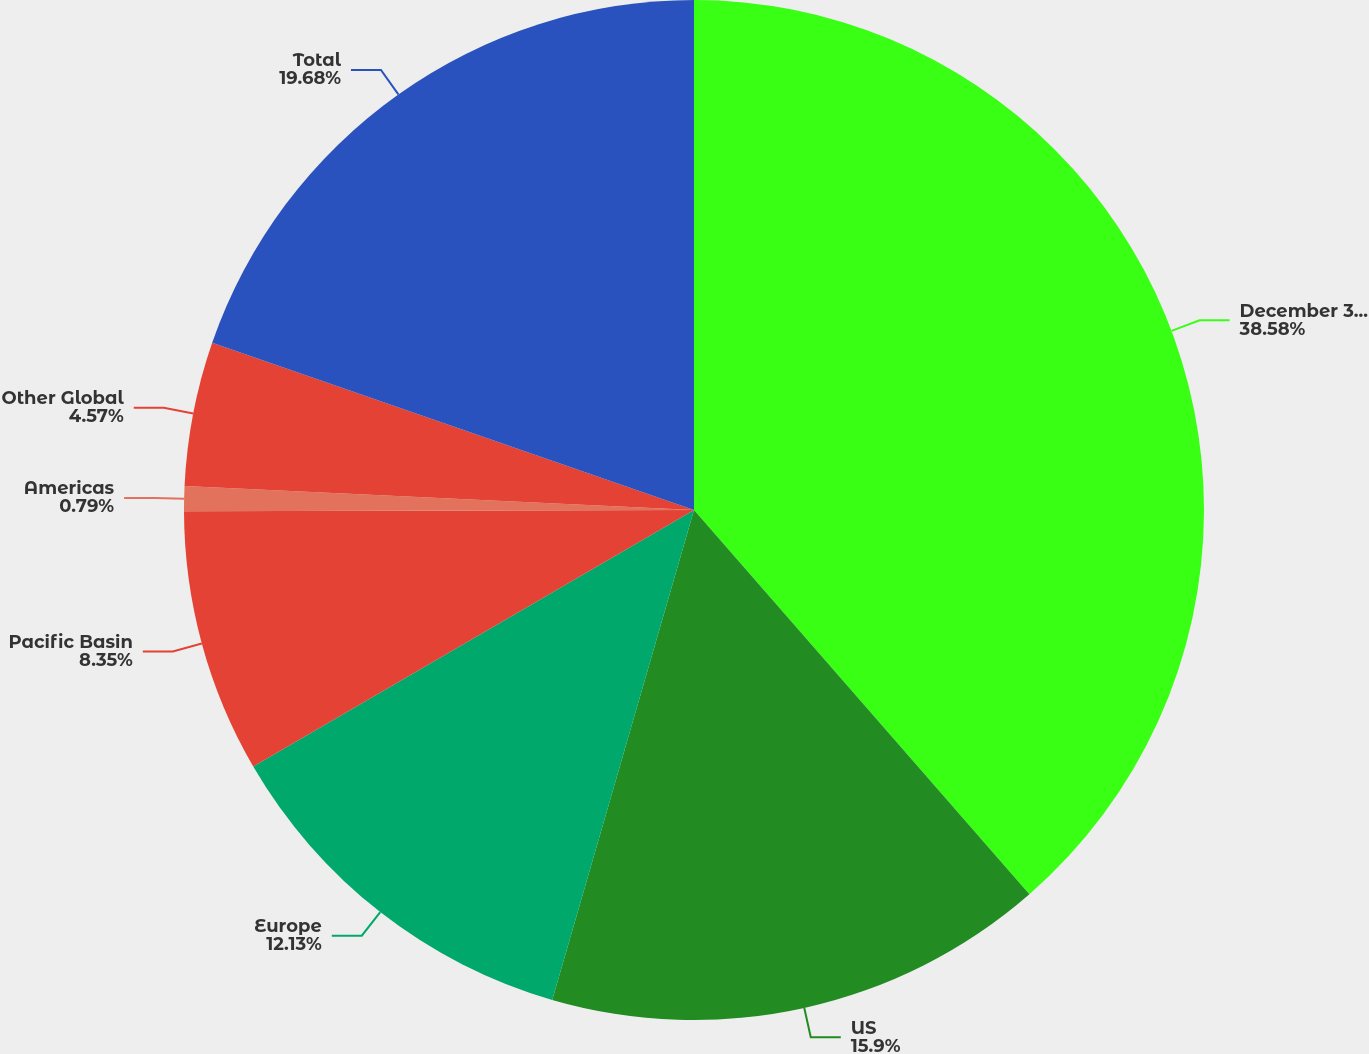Convert chart to OTSL. <chart><loc_0><loc_0><loc_500><loc_500><pie_chart><fcel>December 31 (In billions)<fcel>US<fcel>Europe<fcel>Pacific Basin<fcel>Americas<fcel>Other Global<fcel>Total<nl><fcel>38.59%<fcel>15.91%<fcel>12.13%<fcel>8.35%<fcel>0.79%<fcel>4.57%<fcel>19.69%<nl></chart> 